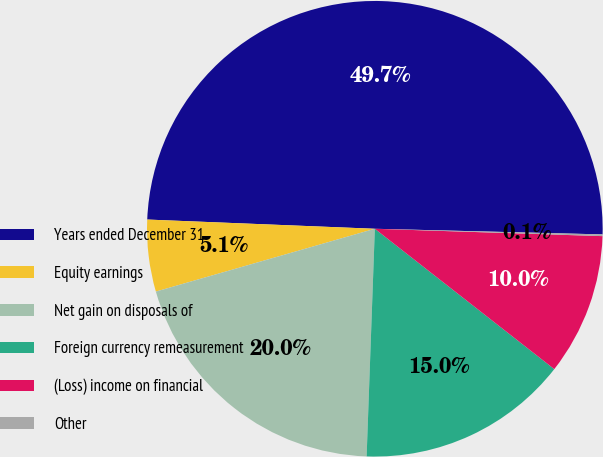Convert chart to OTSL. <chart><loc_0><loc_0><loc_500><loc_500><pie_chart><fcel>Years ended December 31<fcel>Equity earnings<fcel>Net gain on disposals of<fcel>Foreign currency remeasurement<fcel>(Loss) income on financial<fcel>Other<nl><fcel>49.75%<fcel>5.09%<fcel>19.98%<fcel>15.01%<fcel>10.05%<fcel>0.12%<nl></chart> 